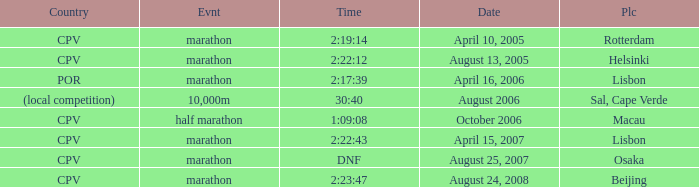What is the Country of the Half Marathon Event? CPV. 